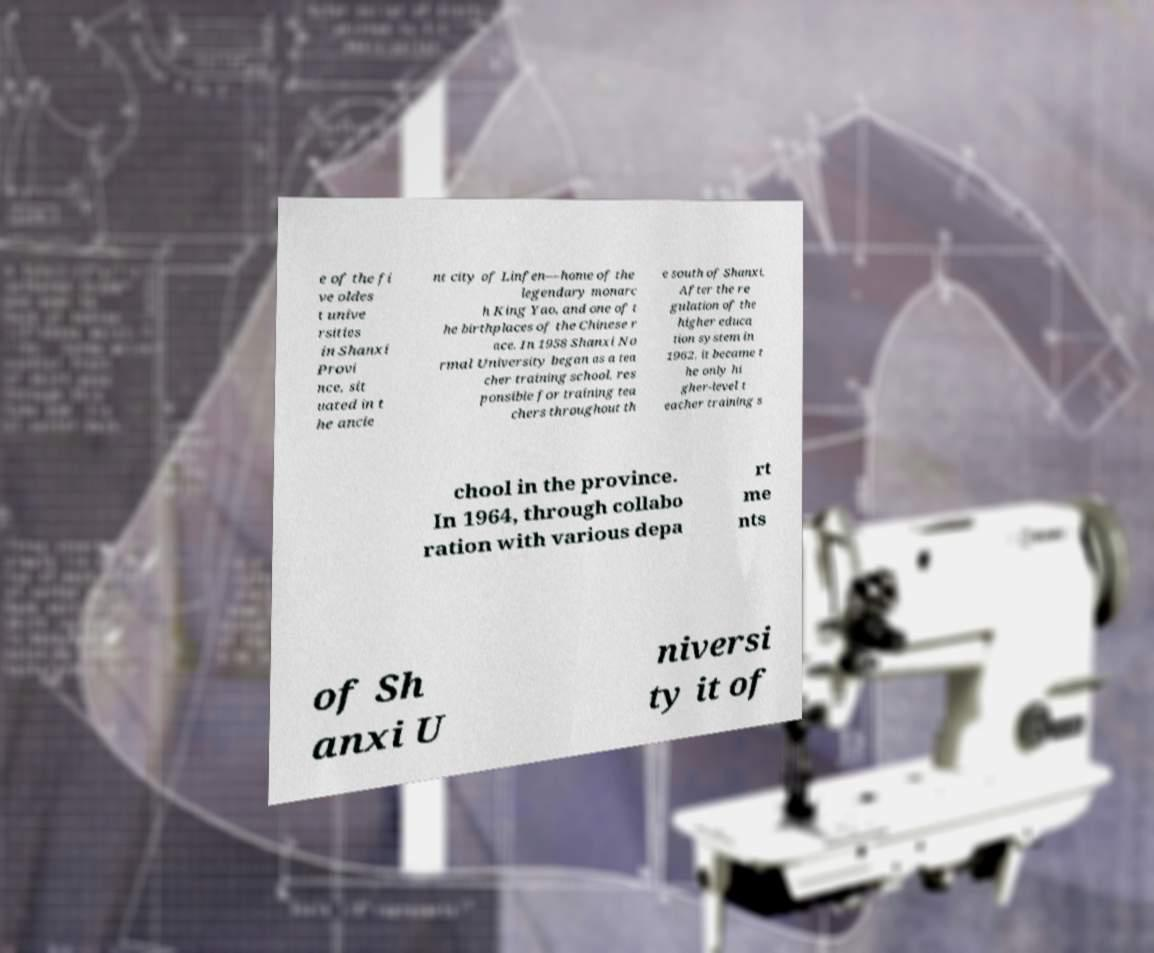Can you accurately transcribe the text from the provided image for me? e of the fi ve oldes t unive rsities in Shanxi Provi nce, sit uated in t he ancie nt city of Linfen—home of the legendary monarc h King Yao, and one of t he birthplaces of the Chinese r ace. In 1958 Shanxi No rmal University began as a tea cher training school, res ponsible for training tea chers throughout th e south of Shanxi. After the re gulation of the higher educa tion system in 1962, it became t he only hi gher-level t eacher training s chool in the province. In 1964, through collabo ration with various depa rt me nts of Sh anxi U niversi ty it of 